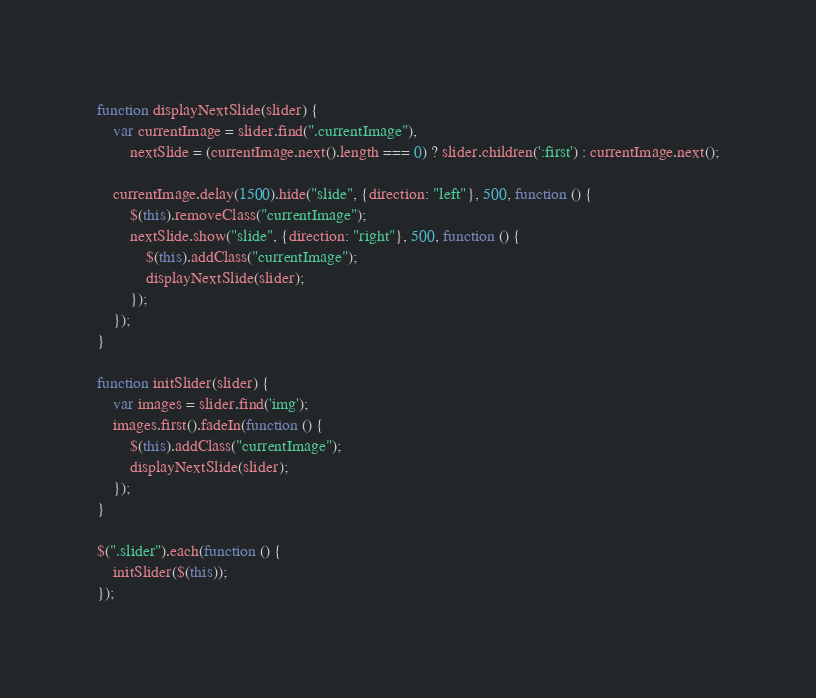<code> <loc_0><loc_0><loc_500><loc_500><_JavaScript_>function displayNextSlide(slider) {
    var currentImage = slider.find(".currentImage"),
        nextSlide = (currentImage.next().length === 0) ? slider.children(':first') : currentImage.next();

    currentImage.delay(1500).hide("slide", {direction: "left"}, 500, function () {
        $(this).removeClass("currentImage");
        nextSlide.show("slide", {direction: "right"}, 500, function () {
            $(this).addClass("currentImage");
            displayNextSlide(slider);
        });
    });
}

function initSlider(slider) {
    var images = slider.find('img');
    images.first().fadeIn(function () {
        $(this).addClass("currentImage");
        displayNextSlide(slider);
    });
}

$(".slider").each(function () {
    initSlider($(this));
});
</code> 